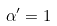Convert formula to latex. <formula><loc_0><loc_0><loc_500><loc_500>\alpha ^ { \prime } = 1</formula> 